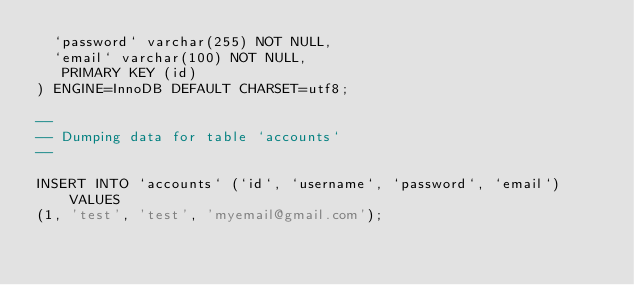Convert code to text. <code><loc_0><loc_0><loc_500><loc_500><_SQL_>  `password` varchar(255) NOT NULL,
  `email` varchar(100) NOT NULL,
   PRIMARY KEY (id)
) ENGINE=InnoDB DEFAULT CHARSET=utf8;

--
-- Dumping data for table `accounts`
--

INSERT INTO `accounts` (`id`, `username`, `password`, `email`) VALUES
(1, 'test', 'test', 'myemail@gmail.com');

</code> 